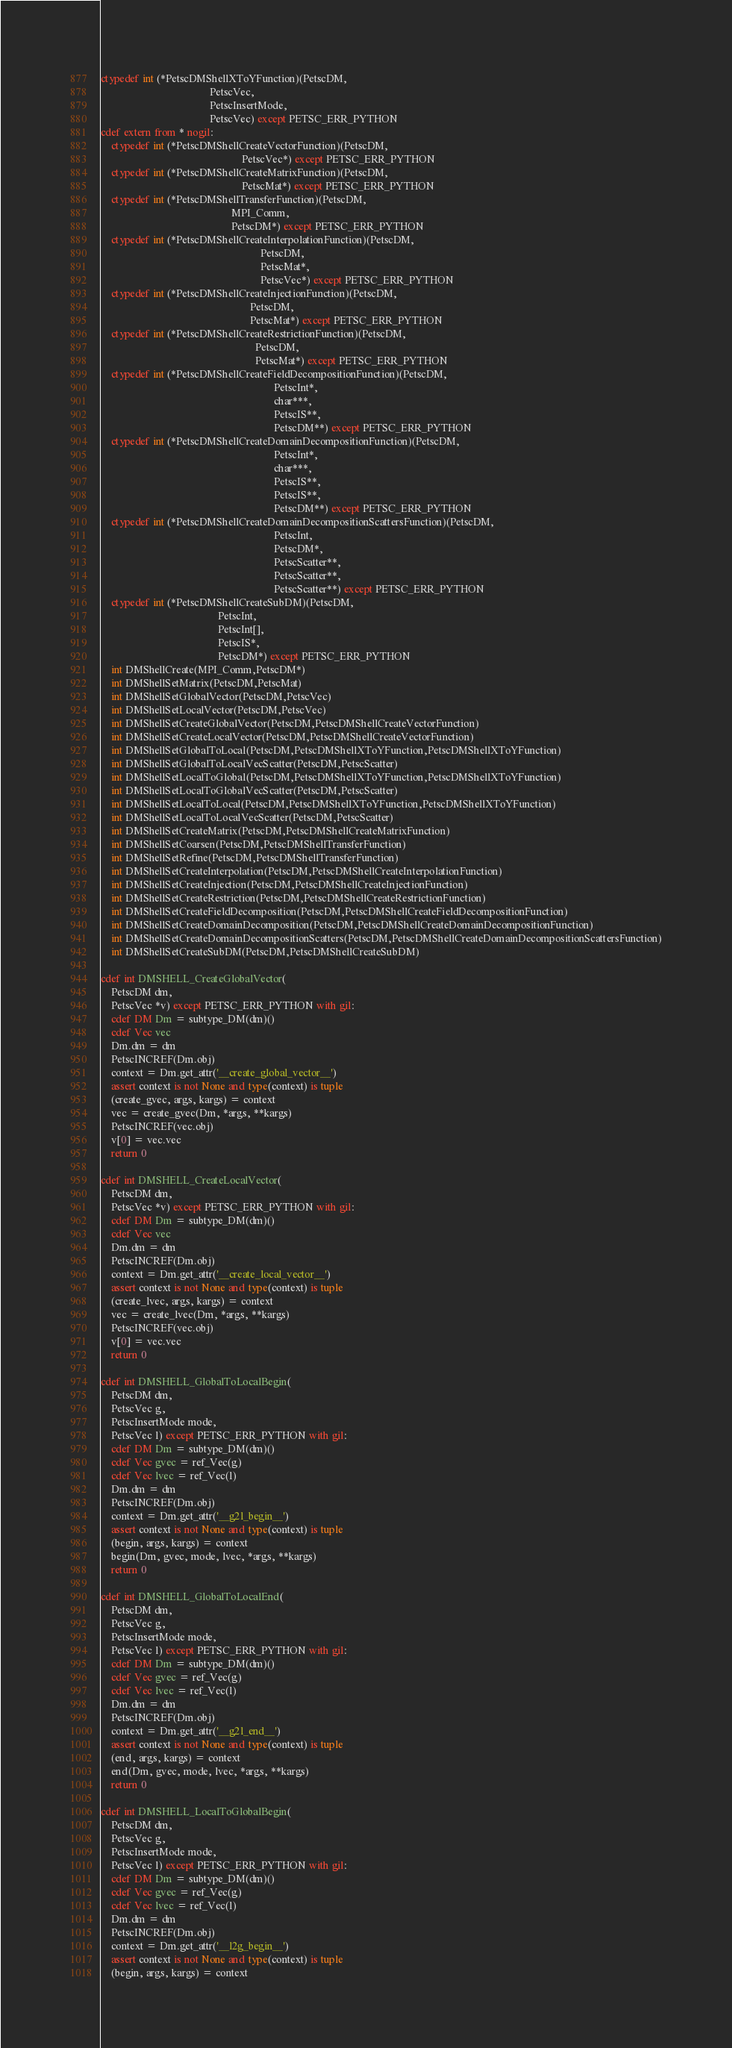<code> <loc_0><loc_0><loc_500><loc_500><_Cython_>ctypedef int (*PetscDMShellXToYFunction)(PetscDM,
                                         PetscVec,
                                         PetscInsertMode,
                                         PetscVec) except PETSC_ERR_PYTHON
cdef extern from * nogil:
    ctypedef int (*PetscDMShellCreateVectorFunction)(PetscDM,
                                                     PetscVec*) except PETSC_ERR_PYTHON
    ctypedef int (*PetscDMShellCreateMatrixFunction)(PetscDM,
                                                     PetscMat*) except PETSC_ERR_PYTHON
    ctypedef int (*PetscDMShellTransferFunction)(PetscDM,
                                                 MPI_Comm,
                                                 PetscDM*) except PETSC_ERR_PYTHON
    ctypedef int (*PetscDMShellCreateInterpolationFunction)(PetscDM,
                                                            PetscDM,
                                                            PetscMat*,
                                                            PetscVec*) except PETSC_ERR_PYTHON
    ctypedef int (*PetscDMShellCreateInjectionFunction)(PetscDM,
                                                        PetscDM,
                                                        PetscMat*) except PETSC_ERR_PYTHON
    ctypedef int (*PetscDMShellCreateRestrictionFunction)(PetscDM,
                                                          PetscDM,
                                                          PetscMat*) except PETSC_ERR_PYTHON
    ctypedef int (*PetscDMShellCreateFieldDecompositionFunction)(PetscDM,
                                                                 PetscInt*,
                                                                 char***,
                                                                 PetscIS**,
                                                                 PetscDM**) except PETSC_ERR_PYTHON
    ctypedef int (*PetscDMShellCreateDomainDecompositionFunction)(PetscDM,
                                                                 PetscInt*,
                                                                 char***,
                                                                 PetscIS**,
                                                                 PetscIS**,
                                                                 PetscDM**) except PETSC_ERR_PYTHON
    ctypedef int (*PetscDMShellCreateDomainDecompositionScattersFunction)(PetscDM,
                                                                 PetscInt,
                                                                 PetscDM*,
                                                                 PetscScatter**,
                                                                 PetscScatter**,
                                                                 PetscScatter**) except PETSC_ERR_PYTHON
    ctypedef int (*PetscDMShellCreateSubDM)(PetscDM,
                                            PetscInt,
                                            PetscInt[],
                                            PetscIS*,
                                            PetscDM*) except PETSC_ERR_PYTHON
    int DMShellCreate(MPI_Comm,PetscDM*)
    int DMShellSetMatrix(PetscDM,PetscMat)
    int DMShellSetGlobalVector(PetscDM,PetscVec)
    int DMShellSetLocalVector(PetscDM,PetscVec)
    int DMShellSetCreateGlobalVector(PetscDM,PetscDMShellCreateVectorFunction)
    int DMShellSetCreateLocalVector(PetscDM,PetscDMShellCreateVectorFunction)
    int DMShellSetGlobalToLocal(PetscDM,PetscDMShellXToYFunction,PetscDMShellXToYFunction)
    int DMShellSetGlobalToLocalVecScatter(PetscDM,PetscScatter)
    int DMShellSetLocalToGlobal(PetscDM,PetscDMShellXToYFunction,PetscDMShellXToYFunction)
    int DMShellSetLocalToGlobalVecScatter(PetscDM,PetscScatter)
    int DMShellSetLocalToLocal(PetscDM,PetscDMShellXToYFunction,PetscDMShellXToYFunction)
    int DMShellSetLocalToLocalVecScatter(PetscDM,PetscScatter)
    int DMShellSetCreateMatrix(PetscDM,PetscDMShellCreateMatrixFunction)
    int DMShellSetCoarsen(PetscDM,PetscDMShellTransferFunction)
    int DMShellSetRefine(PetscDM,PetscDMShellTransferFunction)
    int DMShellSetCreateInterpolation(PetscDM,PetscDMShellCreateInterpolationFunction)
    int DMShellSetCreateInjection(PetscDM,PetscDMShellCreateInjectionFunction)
    int DMShellSetCreateRestriction(PetscDM,PetscDMShellCreateRestrictionFunction)
    int DMShellSetCreateFieldDecomposition(PetscDM,PetscDMShellCreateFieldDecompositionFunction)
    int DMShellSetCreateDomainDecomposition(PetscDM,PetscDMShellCreateDomainDecompositionFunction)
    int DMShellSetCreateDomainDecompositionScatters(PetscDM,PetscDMShellCreateDomainDecompositionScattersFunction)
    int DMShellSetCreateSubDM(PetscDM,PetscDMShellCreateSubDM)

cdef int DMSHELL_CreateGlobalVector(
    PetscDM dm,
    PetscVec *v) except PETSC_ERR_PYTHON with gil:
    cdef DM Dm = subtype_DM(dm)()
    cdef Vec vec
    Dm.dm = dm
    PetscINCREF(Dm.obj)
    context = Dm.get_attr('__create_global_vector__')
    assert context is not None and type(context) is tuple
    (create_gvec, args, kargs) = context
    vec = create_gvec(Dm, *args, **kargs)
    PetscINCREF(vec.obj)
    v[0] = vec.vec
    return 0

cdef int DMSHELL_CreateLocalVector(
    PetscDM dm,
    PetscVec *v) except PETSC_ERR_PYTHON with gil:
    cdef DM Dm = subtype_DM(dm)()
    cdef Vec vec
    Dm.dm = dm
    PetscINCREF(Dm.obj)
    context = Dm.get_attr('__create_local_vector__')
    assert context is not None and type(context) is tuple
    (create_lvec, args, kargs) = context
    vec = create_lvec(Dm, *args, **kargs)
    PetscINCREF(vec.obj)
    v[0] = vec.vec
    return 0

cdef int DMSHELL_GlobalToLocalBegin(
    PetscDM dm,
    PetscVec g,
    PetscInsertMode mode,
    PetscVec l) except PETSC_ERR_PYTHON with gil:
    cdef DM Dm = subtype_DM(dm)()
    cdef Vec gvec = ref_Vec(g)
    cdef Vec lvec = ref_Vec(l)
    Dm.dm = dm
    PetscINCREF(Dm.obj)
    context = Dm.get_attr('__g2l_begin__')
    assert context is not None and type(context) is tuple
    (begin, args, kargs) = context
    begin(Dm, gvec, mode, lvec, *args, **kargs)
    return 0

cdef int DMSHELL_GlobalToLocalEnd(
    PetscDM dm,
    PetscVec g,
    PetscInsertMode mode,
    PetscVec l) except PETSC_ERR_PYTHON with gil:
    cdef DM Dm = subtype_DM(dm)()
    cdef Vec gvec = ref_Vec(g)
    cdef Vec lvec = ref_Vec(l)
    Dm.dm = dm
    PetscINCREF(Dm.obj)
    context = Dm.get_attr('__g2l_end__')
    assert context is not None and type(context) is tuple
    (end, args, kargs) = context
    end(Dm, gvec, mode, lvec, *args, **kargs)
    return 0

cdef int DMSHELL_LocalToGlobalBegin(
    PetscDM dm,
    PetscVec g,
    PetscInsertMode mode,
    PetscVec l) except PETSC_ERR_PYTHON with gil:
    cdef DM Dm = subtype_DM(dm)()
    cdef Vec gvec = ref_Vec(g)
    cdef Vec lvec = ref_Vec(l)
    Dm.dm = dm
    PetscINCREF(Dm.obj)
    context = Dm.get_attr('__l2g_begin__')
    assert context is not None and type(context) is tuple
    (begin, args, kargs) = context</code> 